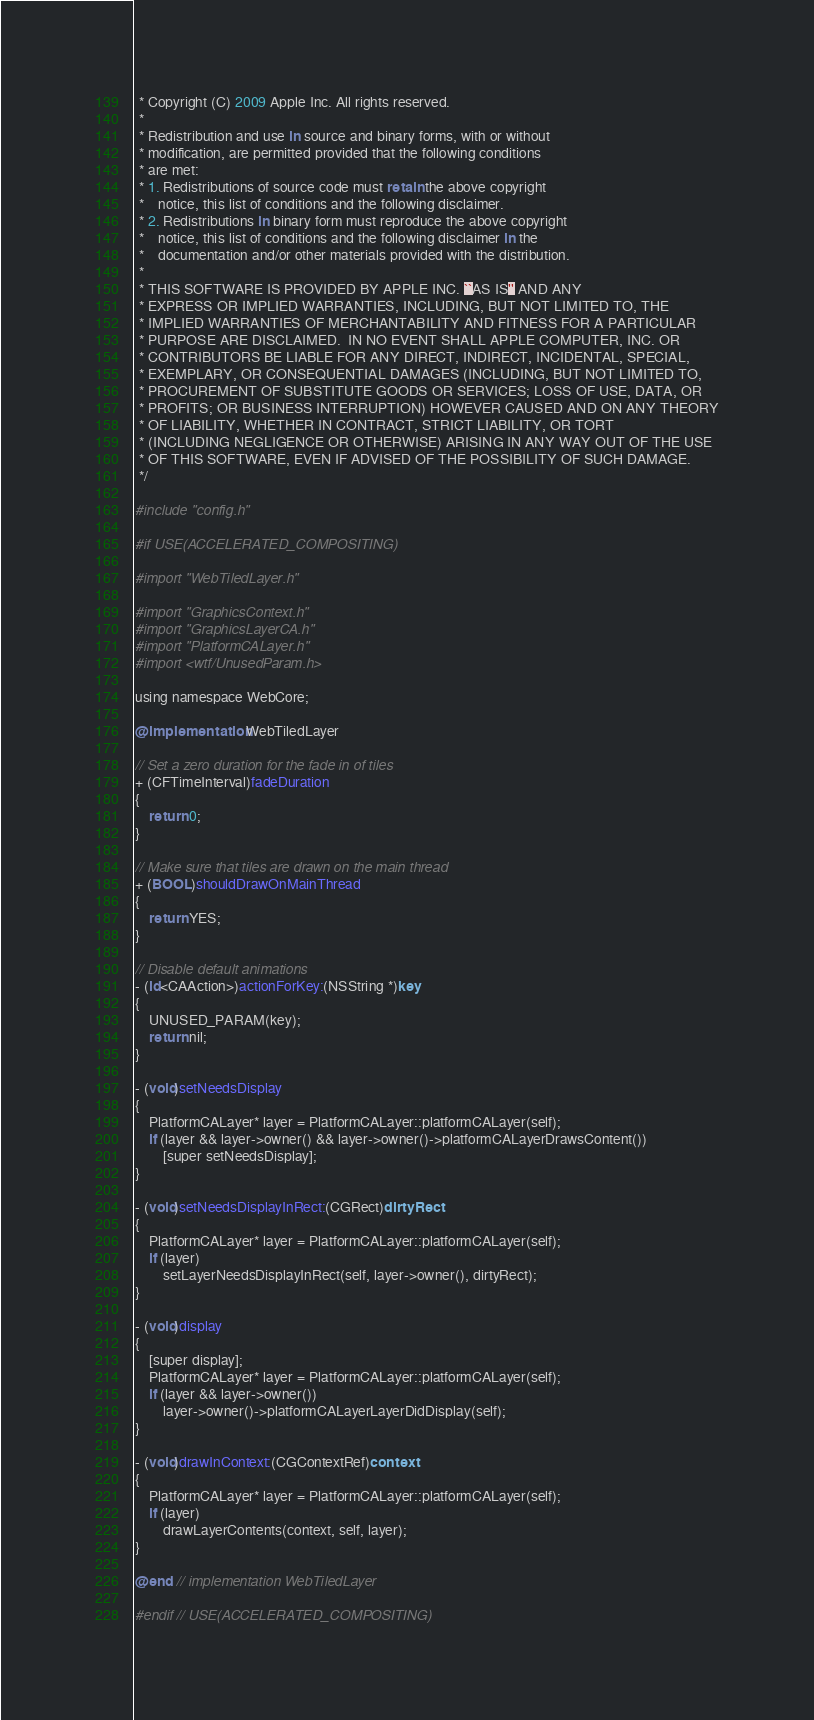Convert code to text. <code><loc_0><loc_0><loc_500><loc_500><_ObjectiveC_> * Copyright (C) 2009 Apple Inc. All rights reserved.
 *
 * Redistribution and use in source and binary forms, with or without
 * modification, are permitted provided that the following conditions
 * are met:
 * 1. Redistributions of source code must retain the above copyright
 *    notice, this list of conditions and the following disclaimer.
 * 2. Redistributions in binary form must reproduce the above copyright
 *    notice, this list of conditions and the following disclaimer in the
 *    documentation and/or other materials provided with the distribution.
 *
 * THIS SOFTWARE IS PROVIDED BY APPLE INC. ``AS IS'' AND ANY
 * EXPRESS OR IMPLIED WARRANTIES, INCLUDING, BUT NOT LIMITED TO, THE
 * IMPLIED WARRANTIES OF MERCHANTABILITY AND FITNESS FOR A PARTICULAR
 * PURPOSE ARE DISCLAIMED.  IN NO EVENT SHALL APPLE COMPUTER, INC. OR
 * CONTRIBUTORS BE LIABLE FOR ANY DIRECT, INDIRECT, INCIDENTAL, SPECIAL,
 * EXEMPLARY, OR CONSEQUENTIAL DAMAGES (INCLUDING, BUT NOT LIMITED TO,
 * PROCUREMENT OF SUBSTITUTE GOODS OR SERVICES; LOSS OF USE, DATA, OR
 * PROFITS; OR BUSINESS INTERRUPTION) HOWEVER CAUSED AND ON ANY THEORY
 * OF LIABILITY, WHETHER IN CONTRACT, STRICT LIABILITY, OR TORT
 * (INCLUDING NEGLIGENCE OR OTHERWISE) ARISING IN ANY WAY OUT OF THE USE
 * OF THIS SOFTWARE, EVEN IF ADVISED OF THE POSSIBILITY OF SUCH DAMAGE. 
 */

#include "config.h"

#if USE(ACCELERATED_COMPOSITING)

#import "WebTiledLayer.h"

#import "GraphicsContext.h"
#import "GraphicsLayerCA.h"
#import "PlatformCALayer.h"
#import <wtf/UnusedParam.h>

using namespace WebCore;

@implementation WebTiledLayer

// Set a zero duration for the fade in of tiles
+ (CFTimeInterval)fadeDuration
{
    return 0;
}

// Make sure that tiles are drawn on the main thread
+ (BOOL)shouldDrawOnMainThread
{
    return YES;
}

// Disable default animations
- (id<CAAction>)actionForKey:(NSString *)key
{
    UNUSED_PARAM(key);
    return nil;
}

- (void)setNeedsDisplay
{
    PlatformCALayer* layer = PlatformCALayer::platformCALayer(self);
    if (layer && layer->owner() && layer->owner()->platformCALayerDrawsContent())
        [super setNeedsDisplay];
}

- (void)setNeedsDisplayInRect:(CGRect)dirtyRect
{
    PlatformCALayer* layer = PlatformCALayer::platformCALayer(self);
    if (layer)
        setLayerNeedsDisplayInRect(self, layer->owner(), dirtyRect);
}

- (void)display
{
    [super display];
    PlatformCALayer* layer = PlatformCALayer::platformCALayer(self);
    if (layer && layer->owner())
        layer->owner()->platformCALayerLayerDidDisplay(self);
}

- (void)drawInContext:(CGContextRef)context
{
    PlatformCALayer* layer = PlatformCALayer::platformCALayer(self);
    if (layer)
        drawLayerContents(context, self, layer);
}

@end // implementation WebTiledLayer

#endif // USE(ACCELERATED_COMPOSITING)
</code> 